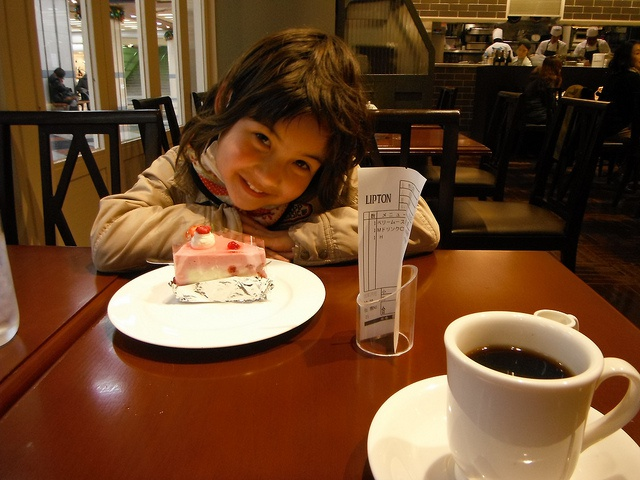Describe the objects in this image and their specific colors. I can see dining table in maroon, brown, and black tones, people in maroon, black, brown, and tan tones, cup in maroon, tan, and gray tones, chair in maroon, black, and darkgray tones, and chair in maroon, black, and olive tones in this image. 